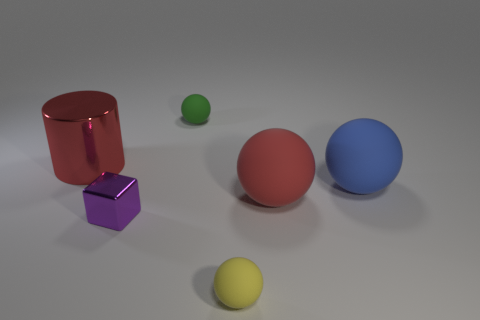What is the material of the large object that is the same color as the cylinder?
Provide a succinct answer. Rubber. There is a block; is it the same color as the small thing that is behind the large cylinder?
Give a very brief answer. No. What is the color of the metal cylinder?
Your answer should be compact. Red. How many things are either large red shiny things or small rubber balls?
Make the answer very short. 3. There is a green ball that is the same size as the yellow thing; what is it made of?
Your answer should be compact. Rubber. There is a rubber object that is in front of the purple metal thing; how big is it?
Provide a succinct answer. Small. What is the material of the cylinder?
Make the answer very short. Metal. How many things are things on the right side of the small yellow matte sphere or objects in front of the tiny green object?
Provide a short and direct response. 5. How many other things are the same color as the metallic cylinder?
Your answer should be compact. 1. Does the tiny green rubber thing have the same shape as the red object to the left of the tiny yellow matte thing?
Give a very brief answer. No. 